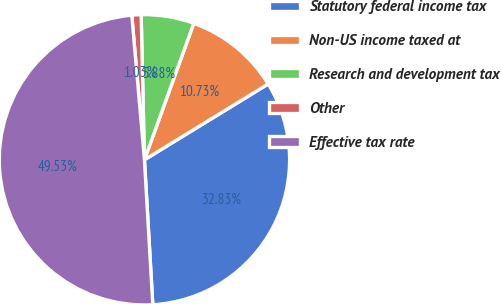<chart> <loc_0><loc_0><loc_500><loc_500><pie_chart><fcel>Statutory federal income tax<fcel>Non-US income taxed at<fcel>Research and development tax<fcel>Other<fcel>Effective tax rate<nl><fcel>32.83%<fcel>10.73%<fcel>5.88%<fcel>1.03%<fcel>49.53%<nl></chart> 